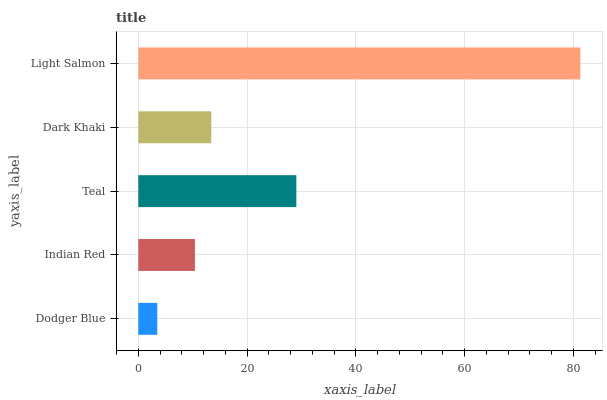Is Dodger Blue the minimum?
Answer yes or no. Yes. Is Light Salmon the maximum?
Answer yes or no. Yes. Is Indian Red the minimum?
Answer yes or no. No. Is Indian Red the maximum?
Answer yes or no. No. Is Indian Red greater than Dodger Blue?
Answer yes or no. Yes. Is Dodger Blue less than Indian Red?
Answer yes or no. Yes. Is Dodger Blue greater than Indian Red?
Answer yes or no. No. Is Indian Red less than Dodger Blue?
Answer yes or no. No. Is Dark Khaki the high median?
Answer yes or no. Yes. Is Dark Khaki the low median?
Answer yes or no. Yes. Is Indian Red the high median?
Answer yes or no. No. Is Teal the low median?
Answer yes or no. No. 